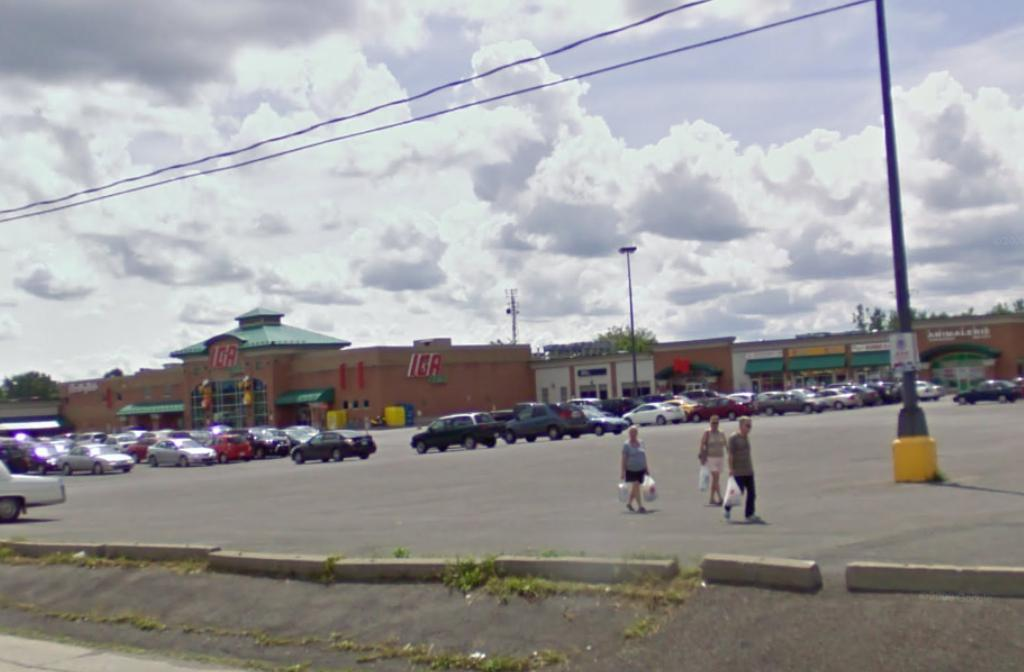<image>
Share a concise interpretation of the image provided. Three people holding bags are walking down a parking lot with an ICA supermarket in the background. 